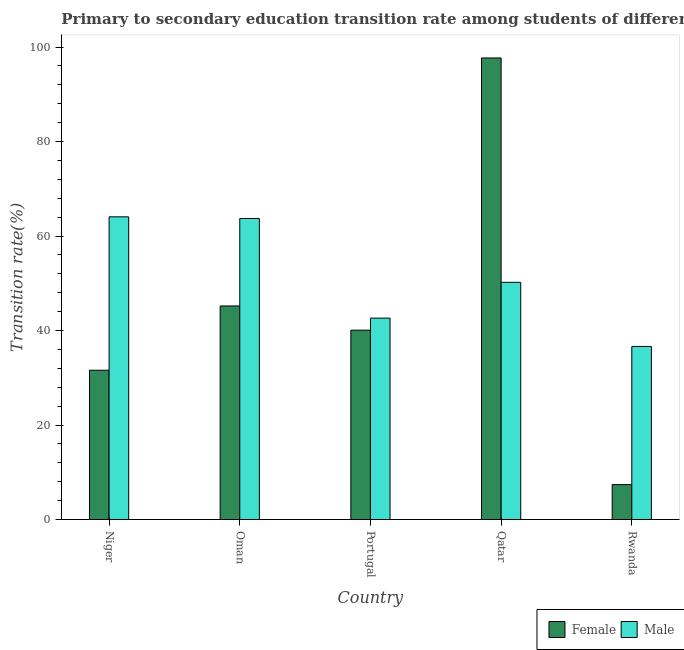Are the number of bars per tick equal to the number of legend labels?
Your response must be concise. Yes. Are the number of bars on each tick of the X-axis equal?
Make the answer very short. Yes. How many bars are there on the 4th tick from the left?
Offer a very short reply. 2. What is the label of the 2nd group of bars from the left?
Your answer should be compact. Oman. In how many cases, is the number of bars for a given country not equal to the number of legend labels?
Ensure brevity in your answer.  0. What is the transition rate among female students in Qatar?
Make the answer very short. 97.7. Across all countries, what is the maximum transition rate among female students?
Your answer should be very brief. 97.7. Across all countries, what is the minimum transition rate among male students?
Ensure brevity in your answer.  36.63. In which country was the transition rate among female students maximum?
Make the answer very short. Qatar. In which country was the transition rate among male students minimum?
Your answer should be very brief. Rwanda. What is the total transition rate among female students in the graph?
Ensure brevity in your answer.  221.97. What is the difference between the transition rate among female students in Oman and that in Qatar?
Provide a succinct answer. -52.5. What is the difference between the transition rate among female students in Portugal and the transition rate among male students in Rwanda?
Offer a terse response. 3.44. What is the average transition rate among female students per country?
Offer a terse response. 44.39. What is the difference between the transition rate among male students and transition rate among female students in Portugal?
Your answer should be compact. 2.55. In how many countries, is the transition rate among female students greater than 60 %?
Make the answer very short. 1. What is the ratio of the transition rate among female students in Niger to that in Rwanda?
Keep it short and to the point. 4.28. Is the difference between the transition rate among male students in Niger and Rwanda greater than the difference between the transition rate among female students in Niger and Rwanda?
Provide a short and direct response. Yes. What is the difference between the highest and the second highest transition rate among male students?
Provide a succinct answer. 0.35. What is the difference between the highest and the lowest transition rate among female students?
Provide a short and direct response. 90.31. In how many countries, is the transition rate among female students greater than the average transition rate among female students taken over all countries?
Offer a very short reply. 2. Is the sum of the transition rate among female students in Qatar and Rwanda greater than the maximum transition rate among male students across all countries?
Give a very brief answer. Yes. What does the 2nd bar from the right in Qatar represents?
Your answer should be very brief. Female. How many bars are there?
Make the answer very short. 10. Are the values on the major ticks of Y-axis written in scientific E-notation?
Your answer should be compact. No. Where does the legend appear in the graph?
Give a very brief answer. Bottom right. How are the legend labels stacked?
Give a very brief answer. Horizontal. What is the title of the graph?
Your answer should be very brief. Primary to secondary education transition rate among students of different countries. What is the label or title of the X-axis?
Your response must be concise. Country. What is the label or title of the Y-axis?
Offer a very short reply. Transition rate(%). What is the Transition rate(%) of Female in Niger?
Offer a very short reply. 31.6. What is the Transition rate(%) in Male in Niger?
Provide a succinct answer. 64.07. What is the Transition rate(%) of Female in Oman?
Your response must be concise. 45.21. What is the Transition rate(%) of Male in Oman?
Your response must be concise. 63.72. What is the Transition rate(%) in Female in Portugal?
Offer a terse response. 40.08. What is the Transition rate(%) of Male in Portugal?
Make the answer very short. 42.63. What is the Transition rate(%) of Female in Qatar?
Make the answer very short. 97.7. What is the Transition rate(%) in Male in Qatar?
Your response must be concise. 50.21. What is the Transition rate(%) in Female in Rwanda?
Offer a very short reply. 7.39. What is the Transition rate(%) of Male in Rwanda?
Keep it short and to the point. 36.63. Across all countries, what is the maximum Transition rate(%) in Female?
Keep it short and to the point. 97.7. Across all countries, what is the maximum Transition rate(%) of Male?
Offer a very short reply. 64.07. Across all countries, what is the minimum Transition rate(%) of Female?
Your answer should be compact. 7.39. Across all countries, what is the minimum Transition rate(%) of Male?
Keep it short and to the point. 36.63. What is the total Transition rate(%) of Female in the graph?
Offer a very short reply. 221.97. What is the total Transition rate(%) of Male in the graph?
Keep it short and to the point. 257.27. What is the difference between the Transition rate(%) in Female in Niger and that in Oman?
Offer a terse response. -13.61. What is the difference between the Transition rate(%) of Male in Niger and that in Oman?
Offer a very short reply. 0.35. What is the difference between the Transition rate(%) in Female in Niger and that in Portugal?
Offer a terse response. -8.48. What is the difference between the Transition rate(%) of Male in Niger and that in Portugal?
Keep it short and to the point. 21.44. What is the difference between the Transition rate(%) of Female in Niger and that in Qatar?
Make the answer very short. -66.1. What is the difference between the Transition rate(%) of Male in Niger and that in Qatar?
Provide a succinct answer. 13.86. What is the difference between the Transition rate(%) in Female in Niger and that in Rwanda?
Your response must be concise. 24.21. What is the difference between the Transition rate(%) in Male in Niger and that in Rwanda?
Your answer should be compact. 27.44. What is the difference between the Transition rate(%) of Female in Oman and that in Portugal?
Keep it short and to the point. 5.13. What is the difference between the Transition rate(%) in Male in Oman and that in Portugal?
Your response must be concise. 21.09. What is the difference between the Transition rate(%) of Female in Oman and that in Qatar?
Make the answer very short. -52.5. What is the difference between the Transition rate(%) in Male in Oman and that in Qatar?
Your answer should be compact. 13.52. What is the difference between the Transition rate(%) of Female in Oman and that in Rwanda?
Ensure brevity in your answer.  37.82. What is the difference between the Transition rate(%) in Male in Oman and that in Rwanda?
Offer a terse response. 27.09. What is the difference between the Transition rate(%) of Female in Portugal and that in Qatar?
Your answer should be compact. -57.62. What is the difference between the Transition rate(%) of Male in Portugal and that in Qatar?
Make the answer very short. -7.58. What is the difference between the Transition rate(%) in Female in Portugal and that in Rwanda?
Offer a very short reply. 32.69. What is the difference between the Transition rate(%) of Male in Portugal and that in Rwanda?
Ensure brevity in your answer.  6. What is the difference between the Transition rate(%) of Female in Qatar and that in Rwanda?
Keep it short and to the point. 90.31. What is the difference between the Transition rate(%) in Male in Qatar and that in Rwanda?
Ensure brevity in your answer.  13.57. What is the difference between the Transition rate(%) in Female in Niger and the Transition rate(%) in Male in Oman?
Offer a terse response. -32.12. What is the difference between the Transition rate(%) of Female in Niger and the Transition rate(%) of Male in Portugal?
Your response must be concise. -11.03. What is the difference between the Transition rate(%) in Female in Niger and the Transition rate(%) in Male in Qatar?
Ensure brevity in your answer.  -18.61. What is the difference between the Transition rate(%) in Female in Niger and the Transition rate(%) in Male in Rwanda?
Ensure brevity in your answer.  -5.03. What is the difference between the Transition rate(%) of Female in Oman and the Transition rate(%) of Male in Portugal?
Offer a terse response. 2.57. What is the difference between the Transition rate(%) in Female in Oman and the Transition rate(%) in Male in Qatar?
Give a very brief answer. -5. What is the difference between the Transition rate(%) of Female in Oman and the Transition rate(%) of Male in Rwanda?
Your response must be concise. 8.57. What is the difference between the Transition rate(%) of Female in Portugal and the Transition rate(%) of Male in Qatar?
Give a very brief answer. -10.13. What is the difference between the Transition rate(%) in Female in Portugal and the Transition rate(%) in Male in Rwanda?
Give a very brief answer. 3.44. What is the difference between the Transition rate(%) of Female in Qatar and the Transition rate(%) of Male in Rwanda?
Keep it short and to the point. 61.07. What is the average Transition rate(%) of Female per country?
Offer a terse response. 44.39. What is the average Transition rate(%) of Male per country?
Offer a very short reply. 51.45. What is the difference between the Transition rate(%) in Female and Transition rate(%) in Male in Niger?
Provide a short and direct response. -32.47. What is the difference between the Transition rate(%) in Female and Transition rate(%) in Male in Oman?
Your answer should be compact. -18.52. What is the difference between the Transition rate(%) in Female and Transition rate(%) in Male in Portugal?
Give a very brief answer. -2.55. What is the difference between the Transition rate(%) in Female and Transition rate(%) in Male in Qatar?
Offer a terse response. 47.49. What is the difference between the Transition rate(%) in Female and Transition rate(%) in Male in Rwanda?
Make the answer very short. -29.25. What is the ratio of the Transition rate(%) of Female in Niger to that in Oman?
Your answer should be very brief. 0.7. What is the ratio of the Transition rate(%) in Male in Niger to that in Oman?
Make the answer very short. 1.01. What is the ratio of the Transition rate(%) of Female in Niger to that in Portugal?
Your answer should be compact. 0.79. What is the ratio of the Transition rate(%) of Male in Niger to that in Portugal?
Your response must be concise. 1.5. What is the ratio of the Transition rate(%) in Female in Niger to that in Qatar?
Offer a very short reply. 0.32. What is the ratio of the Transition rate(%) in Male in Niger to that in Qatar?
Provide a short and direct response. 1.28. What is the ratio of the Transition rate(%) of Female in Niger to that in Rwanda?
Keep it short and to the point. 4.28. What is the ratio of the Transition rate(%) of Male in Niger to that in Rwanda?
Your answer should be very brief. 1.75. What is the ratio of the Transition rate(%) in Female in Oman to that in Portugal?
Ensure brevity in your answer.  1.13. What is the ratio of the Transition rate(%) of Male in Oman to that in Portugal?
Provide a succinct answer. 1.49. What is the ratio of the Transition rate(%) in Female in Oman to that in Qatar?
Give a very brief answer. 0.46. What is the ratio of the Transition rate(%) of Male in Oman to that in Qatar?
Ensure brevity in your answer.  1.27. What is the ratio of the Transition rate(%) in Female in Oman to that in Rwanda?
Your response must be concise. 6.12. What is the ratio of the Transition rate(%) of Male in Oman to that in Rwanda?
Keep it short and to the point. 1.74. What is the ratio of the Transition rate(%) in Female in Portugal to that in Qatar?
Offer a terse response. 0.41. What is the ratio of the Transition rate(%) of Male in Portugal to that in Qatar?
Provide a short and direct response. 0.85. What is the ratio of the Transition rate(%) in Female in Portugal to that in Rwanda?
Provide a short and direct response. 5.42. What is the ratio of the Transition rate(%) in Male in Portugal to that in Rwanda?
Give a very brief answer. 1.16. What is the ratio of the Transition rate(%) in Female in Qatar to that in Rwanda?
Ensure brevity in your answer.  13.22. What is the ratio of the Transition rate(%) of Male in Qatar to that in Rwanda?
Ensure brevity in your answer.  1.37. What is the difference between the highest and the second highest Transition rate(%) of Female?
Keep it short and to the point. 52.5. What is the difference between the highest and the second highest Transition rate(%) of Male?
Make the answer very short. 0.35. What is the difference between the highest and the lowest Transition rate(%) in Female?
Provide a short and direct response. 90.31. What is the difference between the highest and the lowest Transition rate(%) of Male?
Your answer should be compact. 27.44. 